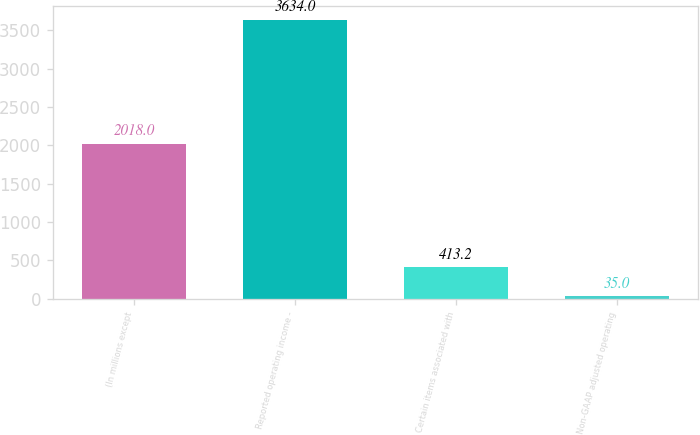Convert chart to OTSL. <chart><loc_0><loc_0><loc_500><loc_500><bar_chart><fcel>(In millions except<fcel>Reported operating income -<fcel>Certain items associated with<fcel>Non-GAAP adjusted operating<nl><fcel>2018<fcel>3634<fcel>413.2<fcel>35<nl></chart> 